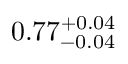<formula> <loc_0><loc_0><loc_500><loc_500>0 . 7 7 _ { - 0 . 0 4 } ^ { + 0 . 0 4 }</formula> 